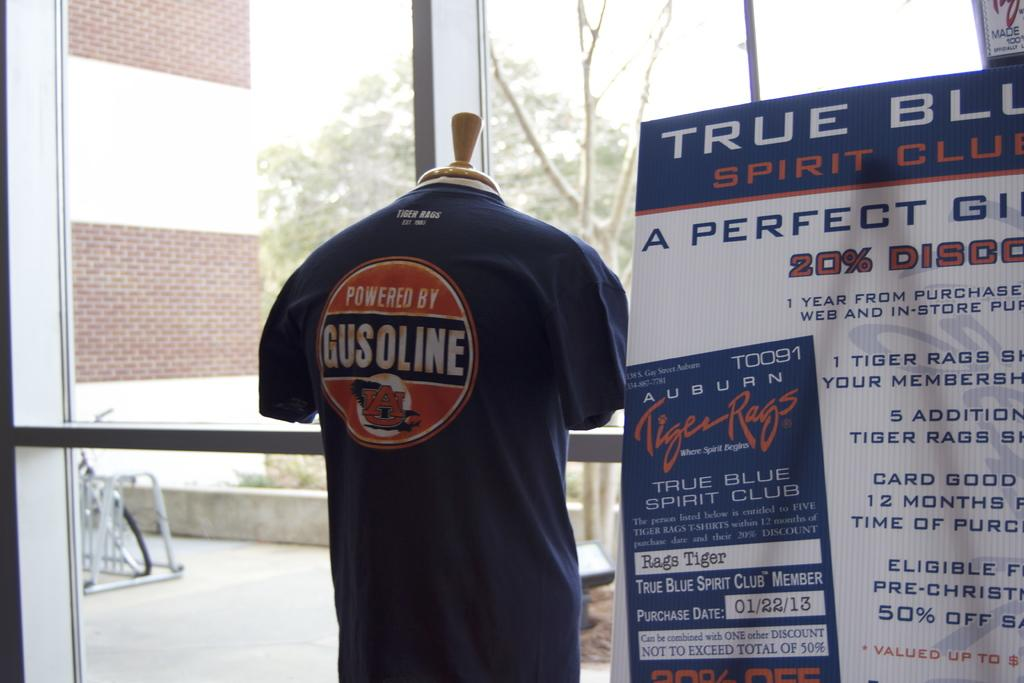<image>
Write a terse but informative summary of the picture. True Blue Spirit Club display and a Powered by Gusoline top. 